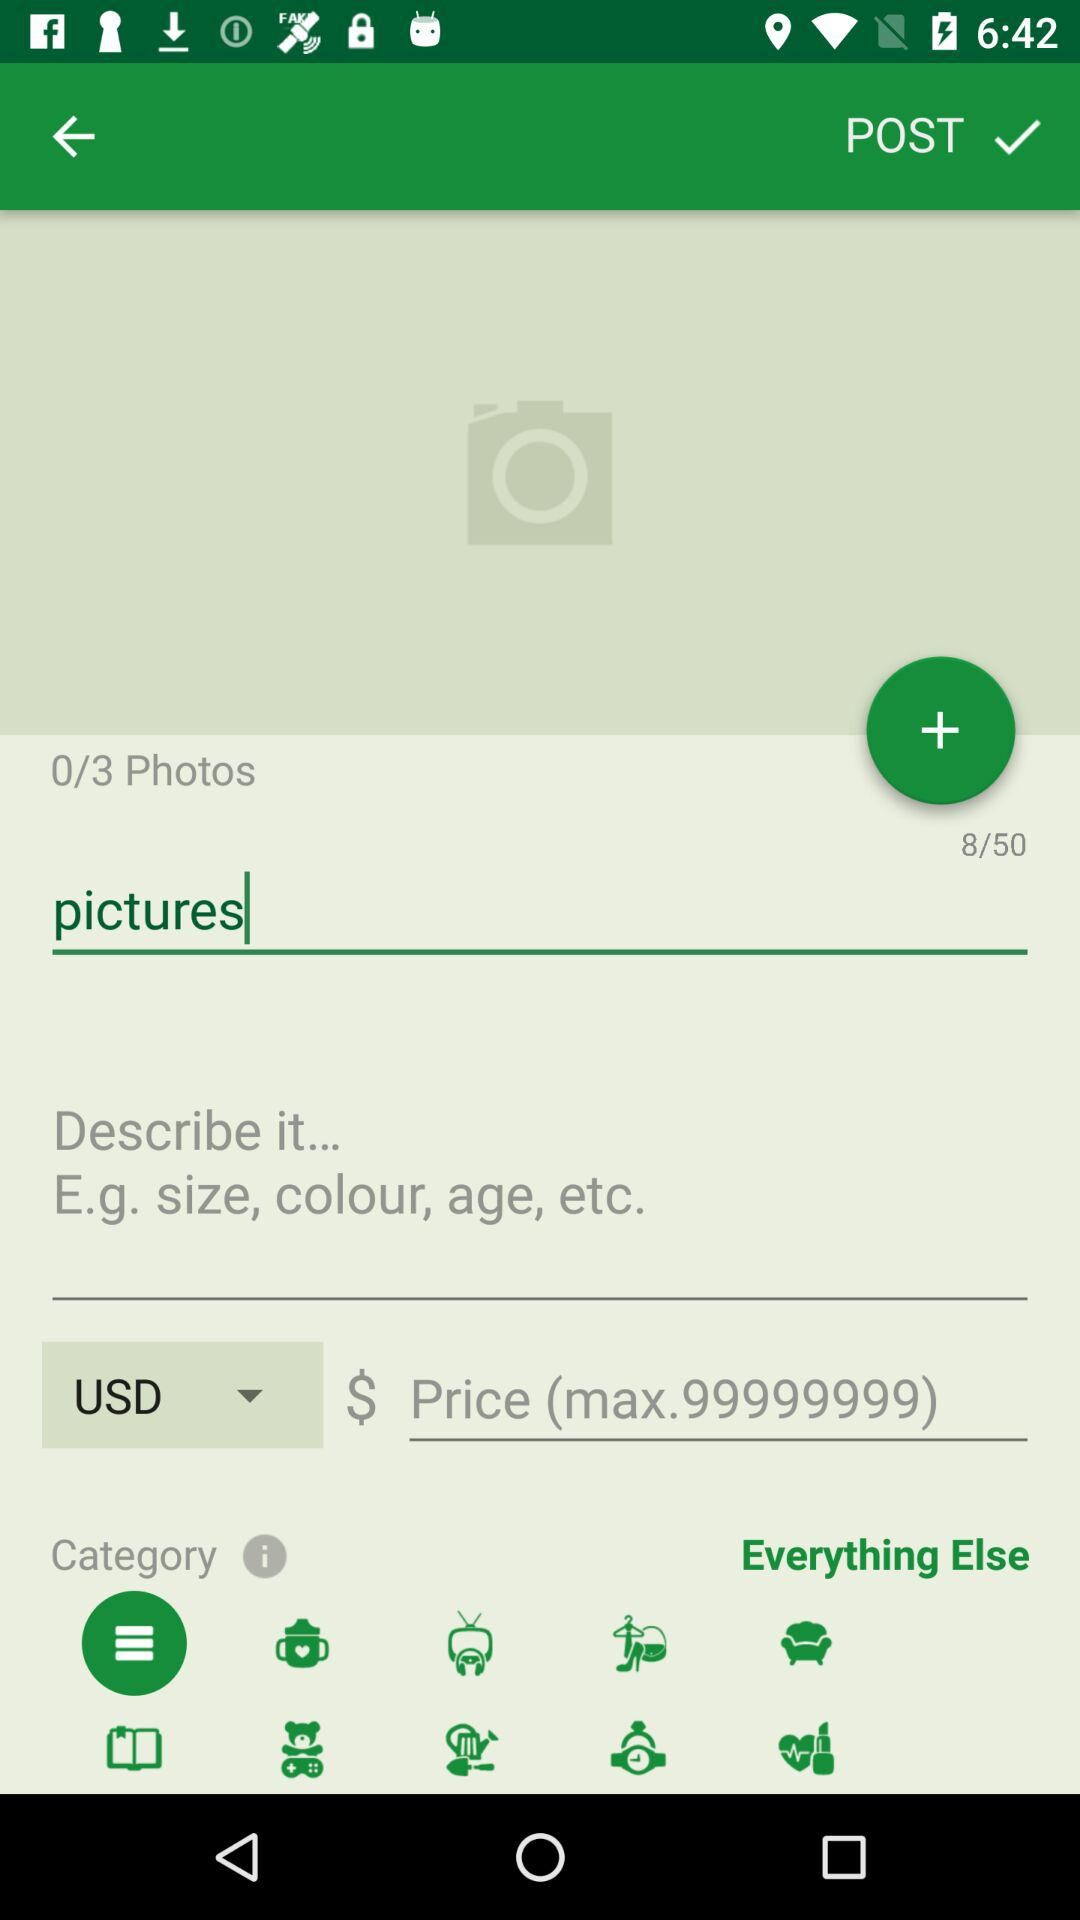What is the selected currency? The selected currency is USD. 